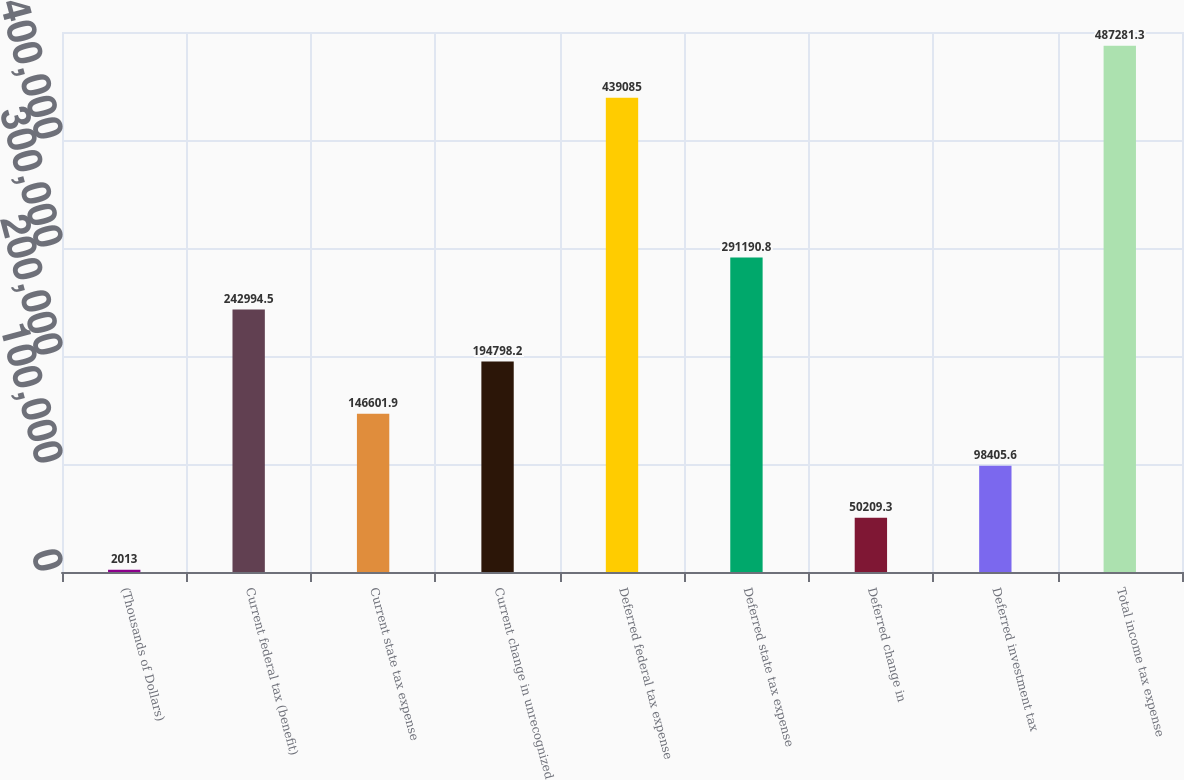Convert chart. <chart><loc_0><loc_0><loc_500><loc_500><bar_chart><fcel>(Thousands of Dollars)<fcel>Current federal tax (benefit)<fcel>Current state tax expense<fcel>Current change in unrecognized<fcel>Deferred federal tax expense<fcel>Deferred state tax expense<fcel>Deferred change in<fcel>Deferred investment tax<fcel>Total income tax expense<nl><fcel>2013<fcel>242994<fcel>146602<fcel>194798<fcel>439085<fcel>291191<fcel>50209.3<fcel>98405.6<fcel>487281<nl></chart> 